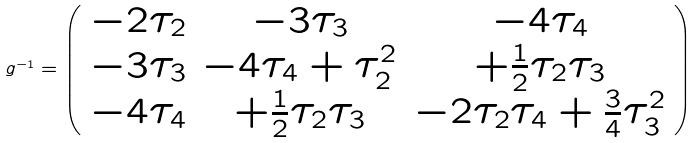<formula> <loc_0><loc_0><loc_500><loc_500>g ^ { - 1 } = \left ( \begin{array} { c c c } - 2 \tau _ { 2 } & - 3 \tau _ { 3 } & - 4 \tau _ { 4 } \\ - 3 \tau _ { 3 } & - 4 \tau _ { 4 } + \tau ^ { 2 } _ { 2 } & + \frac { 1 } { 2 } \tau _ { 2 } \tau _ { 3 } \\ - 4 \tau _ { 4 } & + \frac { 1 } { 2 } \tau _ { 2 } \tau _ { 3 } & - 2 \tau _ { 2 } \tau _ { 4 } + \frac { 3 } { 4 } \tau ^ { 2 } _ { 3 } \end{array} \right )</formula> 